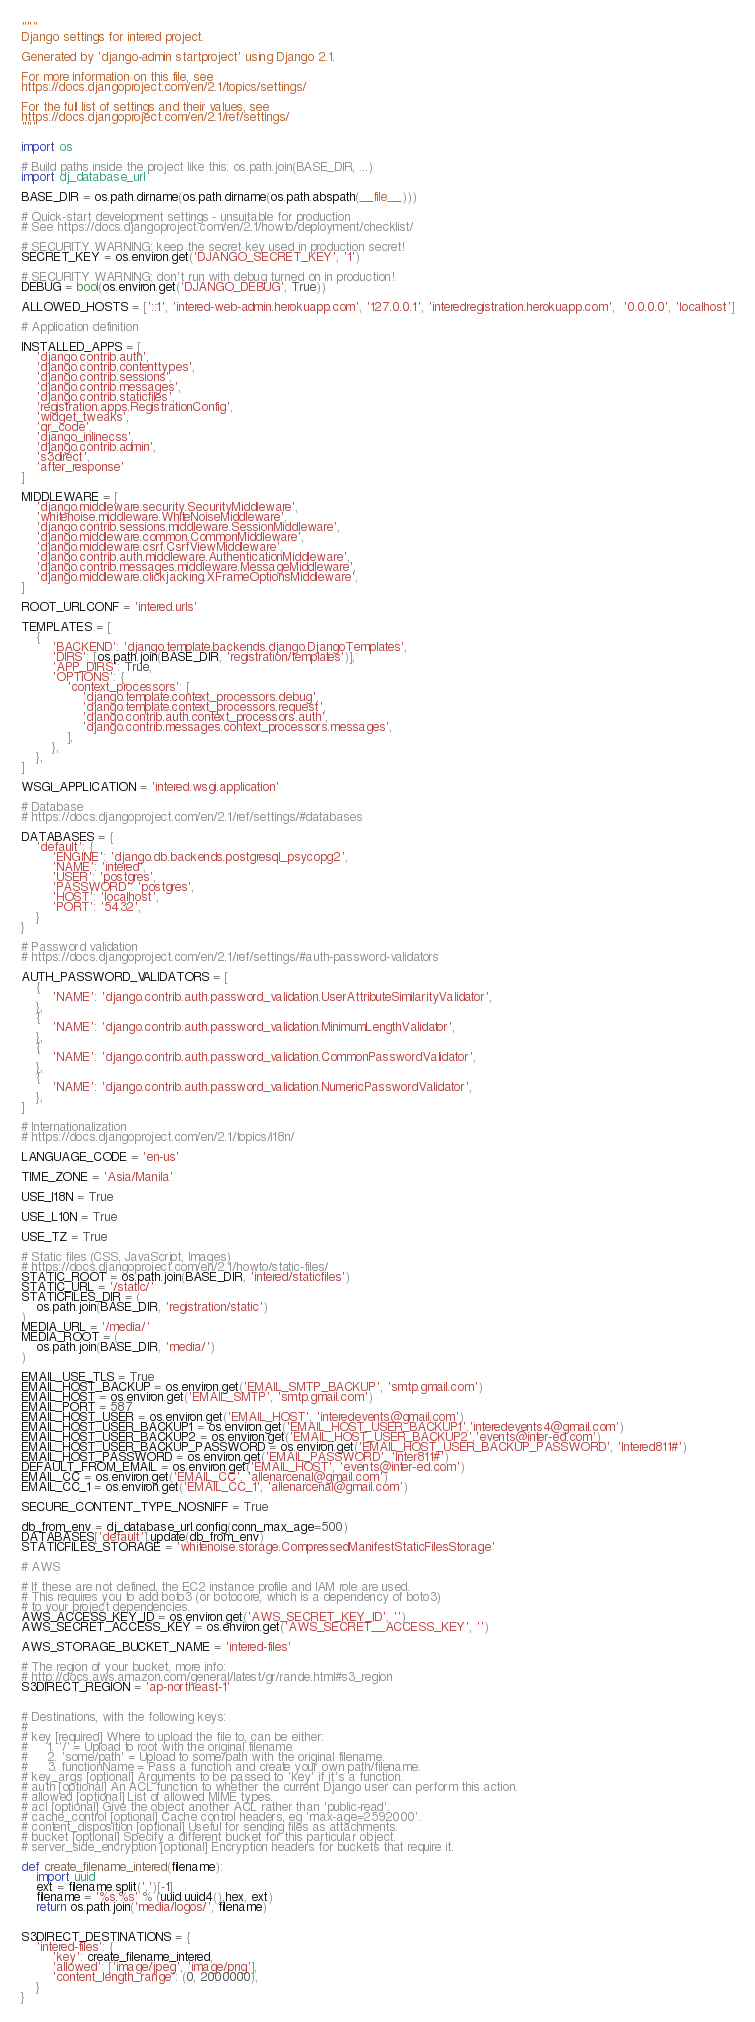Convert code to text. <code><loc_0><loc_0><loc_500><loc_500><_Python_>"""
Django settings for intered project.

Generated by 'django-admin startproject' using Django 2.1.

For more information on this file, see
https://docs.djangoproject.com/en/2.1/topics/settings/

For the full list of settings and their values, see
https://docs.djangoproject.com/en/2.1/ref/settings/
"""

import os

# Build paths inside the project like this: os.path.join(BASE_DIR, ...)
import dj_database_url

BASE_DIR = os.path.dirname(os.path.dirname(os.path.abspath(__file__)))

# Quick-start development settings - unsuitable for production
# See https://docs.djangoproject.com/en/2.1/howto/deployment/checklist/

# SECURITY WARNING: keep the secret key used in production secret!
SECRET_KEY = os.environ.get('DJANGO_SECRET_KEY', '1')

# SECURITY WARNING: don't run with debug turned on in production!
DEBUG = bool(os.environ.get('DJANGO_DEBUG', True))

ALLOWED_HOSTS = ['::1', 'intered-web-admin.herokuapp.com', '127.0.0.1', 'interedregistration.herokuapp.com',  '0.0.0.0', 'localhost']

# Application definition

INSTALLED_APPS = [
    'django.contrib.auth',
    'django.contrib.contenttypes',
    'django.contrib.sessions',
    'django.contrib.messages',
    'django.contrib.staticfiles',
    'registration.apps.RegistrationConfig',
    'widget_tweaks',
    'qr_code',
    'django_inlinecss',
    'django.contrib.admin',
    's3direct',
    'after_response'
]

MIDDLEWARE = [
    'django.middleware.security.SecurityMiddleware',
    'whitenoise.middleware.WhiteNoiseMiddleware',
    'django.contrib.sessions.middleware.SessionMiddleware',
    'django.middleware.common.CommonMiddleware',
    'django.middleware.csrf.CsrfViewMiddleware',
    'django.contrib.auth.middleware.AuthenticationMiddleware',
    'django.contrib.messages.middleware.MessageMiddleware',
    'django.middleware.clickjacking.XFrameOptionsMiddleware',
]

ROOT_URLCONF = 'intered.urls'

TEMPLATES = [
    {
        'BACKEND': 'django.template.backends.django.DjangoTemplates',
        'DIRS': [os.path.join(BASE_DIR, 'registration/templates')],
        'APP_DIRS': True,
        'OPTIONS': {
            'context_processors': [
                'django.template.context_processors.debug',
                'django.template.context_processors.request',
                'django.contrib.auth.context_processors.auth',
                'django.contrib.messages.context_processors.messages',
            ],
        },
    },
]

WSGI_APPLICATION = 'intered.wsgi.application'

# Database
# https://docs.djangoproject.com/en/2.1/ref/settings/#databases

DATABASES = {
    'default': {
        'ENGINE': 'django.db.backends.postgresql_psycopg2',
        'NAME': 'intered',
        'USER': 'postgres',
        'PASSWORD': 'postgres',
        'HOST': 'localhost',
        'PORT': '5432',
    }
}

# Password validation
# https://docs.djangoproject.com/en/2.1/ref/settings/#auth-password-validators

AUTH_PASSWORD_VALIDATORS = [
    {
        'NAME': 'django.contrib.auth.password_validation.UserAttributeSimilarityValidator',
    },
    {
        'NAME': 'django.contrib.auth.password_validation.MinimumLengthValidator',
    },
    {
        'NAME': 'django.contrib.auth.password_validation.CommonPasswordValidator',
    },
    {
        'NAME': 'django.contrib.auth.password_validation.NumericPasswordValidator',
    },
]

# Internationalization
# https://docs.djangoproject.com/en/2.1/topics/i18n/

LANGUAGE_CODE = 'en-us'

TIME_ZONE = 'Asia/Manila'

USE_I18N = True

USE_L10N = True

USE_TZ = True

# Static files (CSS, JavaScript, Images)
# https://docs.djangoproject.com/en/2.1/howto/static-files/
STATIC_ROOT = os.path.join(BASE_DIR, 'intered/staticfiles')
STATIC_URL = '/static/'
STATICFILES_DIR = (
    os.path.join(BASE_DIR, 'registration/static')
)
MEDIA_URL = '/media/'
MEDIA_ROOT = (
    os.path.join(BASE_DIR, 'media/')
)

EMAIL_USE_TLS = True
EMAIL_HOST_BACKUP = os.environ.get('EMAIL_SMTP_BACKUP', 'smtp.gmail.com')
EMAIL_HOST = os.environ.get('EMAIL_SMTP', 'smtp.gmail.com')
EMAIL_PORT = 587
EMAIL_HOST_USER = os.environ.get('EMAIL_HOST', 'interedevents@gmail.com')
EMAIL_HOST_USER_BACKUP1 = os.environ.get('EMAIL_HOST_USER_BACKUP1','interedevents4@gmail.com')
EMAIL_HOST_USER_BACKUP2 = os.environ.get('EMAIL_HOST_USER_BACKUP2','events@inter-ed.com')
EMAIL_HOST_USER_BACKUP_PASSWORD = os.environ.get('EMAIL_HOST_USER_BACKUP_PASSWORD', 'Intered811#')
EMAIL_HOST_PASSWORD = os.environ.get('EMAIL_PASSWORD', 'Inter811#')
DEFAULT_FROM_EMAIL = os.environ.get('EMAIL_HOST', 'events@inter-ed.com')
EMAIL_CC = os.environ.get('EMAIL_CC', 'allenarcenal@gmail.com')
EMAIL_CC_1 = os.environ.get('EMAIL_CC_1', 'allenarcenal@gmail.com')

SECURE_CONTENT_TYPE_NOSNIFF = True

db_from_env = dj_database_url.config(conn_max_age=500)
DATABASES['default'].update(db_from_env)
STATICFILES_STORAGE = 'whitenoise.storage.CompressedManifestStaticFilesStorage'

# AWS

# If these are not defined, the EC2 instance profile and IAM role are used.
# This requires you to add boto3 (or botocore, which is a dependency of boto3)
# to your project dependencies.
AWS_ACCESS_KEY_ID = os.environ.get('AWS_SECRET_KEY_ID', '')
AWS_SECRET_ACCESS_KEY = os.environ.get('AWS_SECRET__ACCESS_KEY', '')

AWS_STORAGE_BUCKET_NAME = 'intered-files'

# The region of your bucket, more info:
# http://docs.aws.amazon.com/general/latest/gr/rande.html#s3_region
S3DIRECT_REGION = 'ap-northeast-1'


# Destinations, with the following keys:
#
# key [required] Where to upload the file to, can be either:
#     1. '/' = Upload to root with the original filename.
#     2. 'some/path' = Upload to some/path with the original filename.
#     3. functionName = Pass a function and create your own path/filename.
# key_args [optional] Arguments to be passed to 'key' if it's a function.
# auth [optional] An ACL function to whether the current Django user can perform this action.
# allowed [optional] List of allowed MIME types.
# acl [optional] Give the object another ACL rather than 'public-read'.
# cache_control [optional] Cache control headers, eg 'max-age=2592000'.
# content_disposition [optional] Useful for sending files as attachments.
# bucket [optional] Specify a different bucket for this particular object.
# server_side_encryption [optional] Encryption headers for buckets that require it.

def create_filename_intered(filename):
    import uuid
    ext = filename.split('.')[-1]
    filename = '%s.%s' % (uuid.uuid4().hex, ext)
    return os.path.join('media/logos/', filename)


S3DIRECT_DESTINATIONS = {
    'intered-files': {
        'key': create_filename_intered,
        'allowed': ['image/jpeg', 'image/png'],
        'content_length_range': (0, 2000000),
    }
}
</code> 